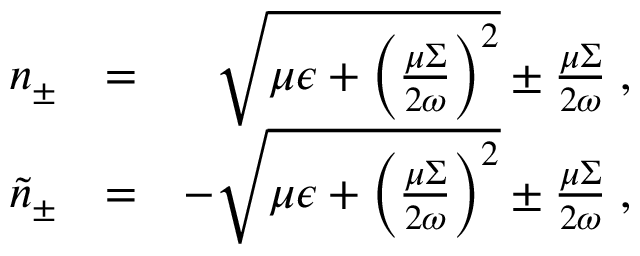<formula> <loc_0><loc_0><loc_500><loc_500>\begin{array} { r l r } { n _ { \pm } } & { = } & { \sqrt { \mu \epsilon + \left ( \frac { \mu \Sigma } { 2 \omega } \right ) ^ { 2 } } \pm \frac { \mu \Sigma } { 2 \omega } \, , } \\ { \tilde { n } _ { \pm } } & { = } & { - \sqrt { \mu \epsilon + \left ( \frac { \mu \Sigma } { 2 \omega } \right ) ^ { 2 } } \pm \frac { \mu \Sigma } { 2 \omega } \, , } \end{array}</formula> 